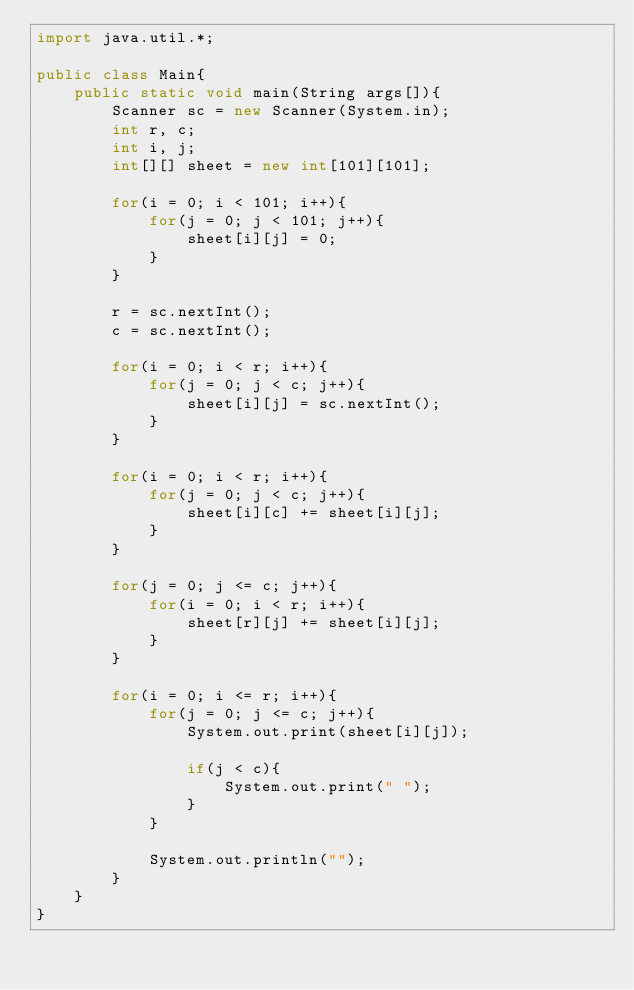<code> <loc_0><loc_0><loc_500><loc_500><_Java_>import java.util.*;

public class Main{
	public static void main(String args[]){
		Scanner sc = new Scanner(System.in);
		int r, c;
		int i, j;
		int[][] sheet = new int[101][101];
		
		for(i = 0; i < 101; i++){
			for(j = 0; j < 101; j++){
				sheet[i][j] = 0;
			}
		}
		
		r = sc.nextInt();
		c = sc.nextInt();
		
		for(i = 0; i < r; i++){
			for(j = 0; j < c; j++){
				sheet[i][j] = sc.nextInt();
			}
		}
		
		for(i = 0; i < r; i++){
			for(j = 0; j < c; j++){
				sheet[i][c] += sheet[i][j];
			}
		}
		
		for(j = 0; j <= c; j++){
			for(i = 0; i < r; i++){
				sheet[r][j] += sheet[i][j];
			}
		}
		
		for(i = 0; i <= r; i++){
			for(j = 0; j <= c; j++){
				System.out.print(sheet[i][j]);
				
				if(j < c){
					System.out.print(" ");
				}
			}
			
			System.out.println("");
		}
	}
}</code> 